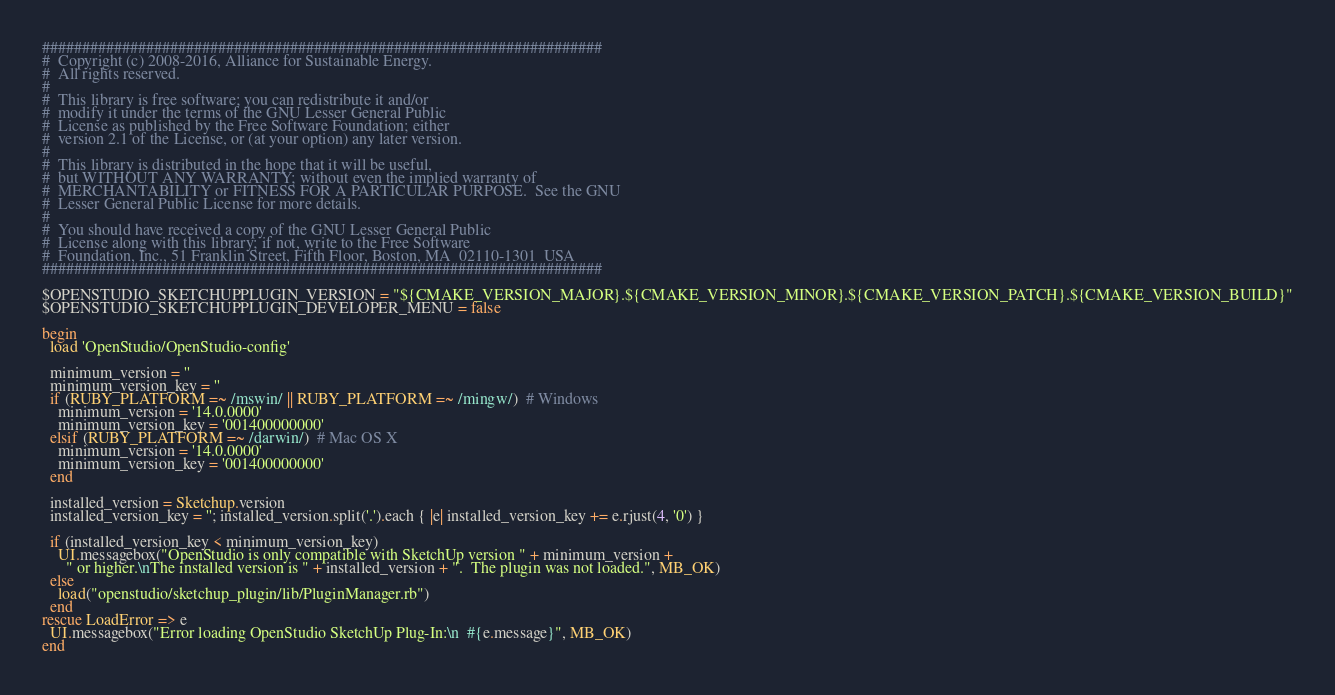Convert code to text. <code><loc_0><loc_0><loc_500><loc_500><_Ruby_>######################################################################
#  Copyright (c) 2008-2016, Alliance for Sustainable Energy.  
#  All rights reserved.
#  
#  This library is free software; you can redistribute it and/or
#  modify it under the terms of the GNU Lesser General Public
#  License as published by the Free Software Foundation; either
#  version 2.1 of the License, or (at your option) any later version.
#  
#  This library is distributed in the hope that it will be useful,
#  but WITHOUT ANY WARRANTY; without even the implied warranty of
#  MERCHANTABILITY or FITNESS FOR A PARTICULAR PURPOSE.  See the GNU
#  Lesser General Public License for more details.
#  
#  You should have received a copy of the GNU Lesser General Public
#  License along with this library; if not, write to the Free Software
#  Foundation, Inc., 51 Franklin Street, Fifth Floor, Boston, MA  02110-1301  USA
######################################################################

$OPENSTUDIO_SKETCHUPPLUGIN_VERSION = "${CMAKE_VERSION_MAJOR}.${CMAKE_VERSION_MINOR}.${CMAKE_VERSION_PATCH}.${CMAKE_VERSION_BUILD}"
$OPENSTUDIO_SKETCHUPPLUGIN_DEVELOPER_MENU = false

begin
  load 'OpenStudio/OpenStudio-config'

  minimum_version = ''
  minimum_version_key = ''
  if (RUBY_PLATFORM =~ /mswin/ || RUBY_PLATFORM =~ /mingw/)  # Windows
    minimum_version = '14.0.0000'
    minimum_version_key = '001400000000'
  elsif (RUBY_PLATFORM =~ /darwin/)  # Mac OS X
    minimum_version = '14.0.0000'
    minimum_version_key = '001400000000'
  end

  installed_version = Sketchup.version
  installed_version_key = ''; installed_version.split('.').each { |e| installed_version_key += e.rjust(4, '0') }

  if (installed_version_key < minimum_version_key)
    UI.messagebox("OpenStudio is only compatible with SketchUp version " + minimum_version +
      " or higher.\nThe installed version is " + installed_version + ".  The plugin was not loaded.", MB_OK)
  else
    load("openstudio/sketchup_plugin/lib/PluginManager.rb")
  end
rescue LoadError => e 
  UI.messagebox("Error loading OpenStudio SketchUp Plug-In:\n  #{e.message}", MB_OK)
end
</code> 